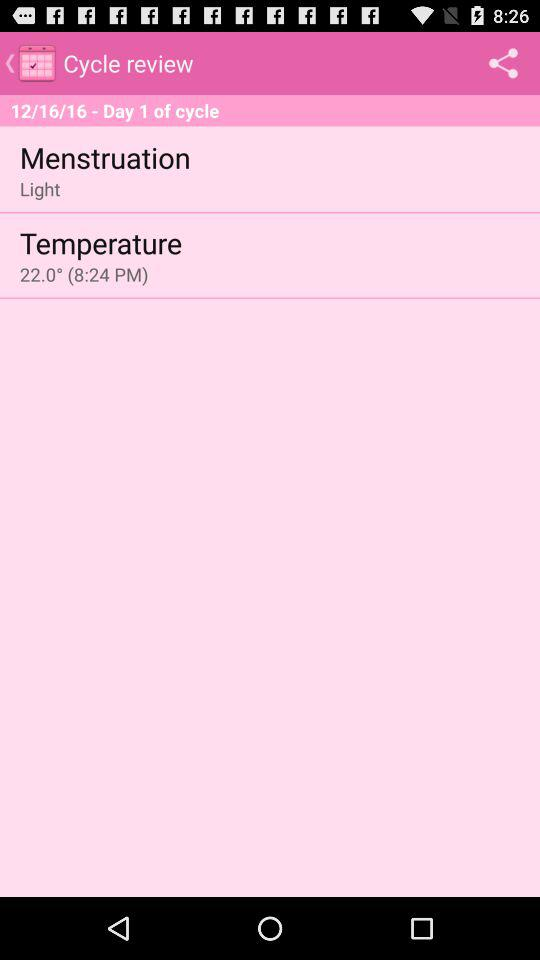What is the date of day one of the cycle? The date of day one of the cycle is December 16, 2016. 